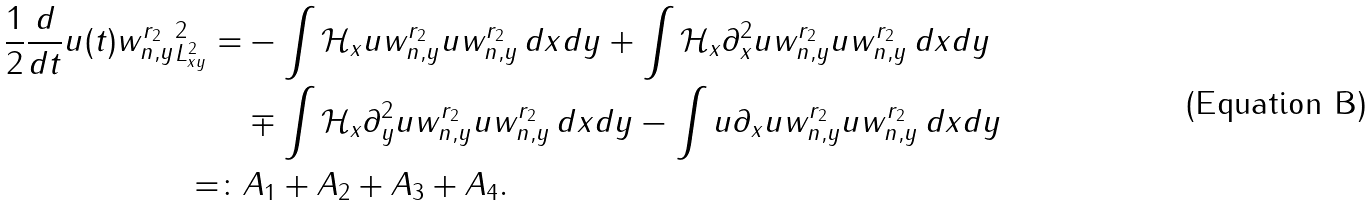Convert formula to latex. <formula><loc_0><loc_0><loc_500><loc_500>\frac { 1 } { 2 } \frac { d } { d t } \| u ( t ) w _ { n , y } ^ { r _ { 2 } } \| _ { L ^ { 2 } _ { x y } } ^ { 2 } = & - \int \mathcal { H } _ { x } u w _ { n , y } ^ { r _ { 2 } } u w _ { n , y } ^ { r _ { 2 } } \, d x d y + \int \mathcal { H } _ { x } \partial _ { x } ^ { 2 } u w _ { n , y } ^ { r _ { 2 } } u w _ { n , y } ^ { r _ { 2 } } \, d x d y \\ & \mp \int \mathcal { H } _ { x } \partial _ { y } ^ { 2 } u w _ { n , y } ^ { r _ { 2 } } u w _ { n , y } ^ { r _ { 2 } } \, d x d y - \int u \partial _ { x } u w _ { n , y } ^ { r _ { 2 } } u w _ { n , y } ^ { r _ { 2 } } \, d x d y \\ = \colon & A _ { 1 } + A _ { 2 } + A _ { 3 } + A _ { 4 } .</formula> 